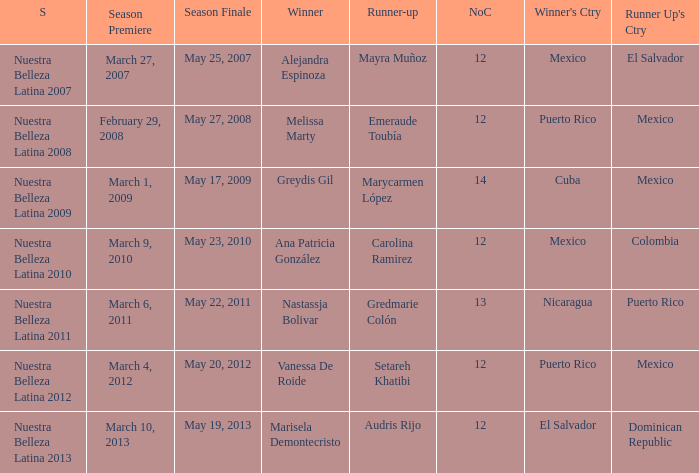What season's premiere had puerto rico winning on May 20, 2012? March 4, 2012. 